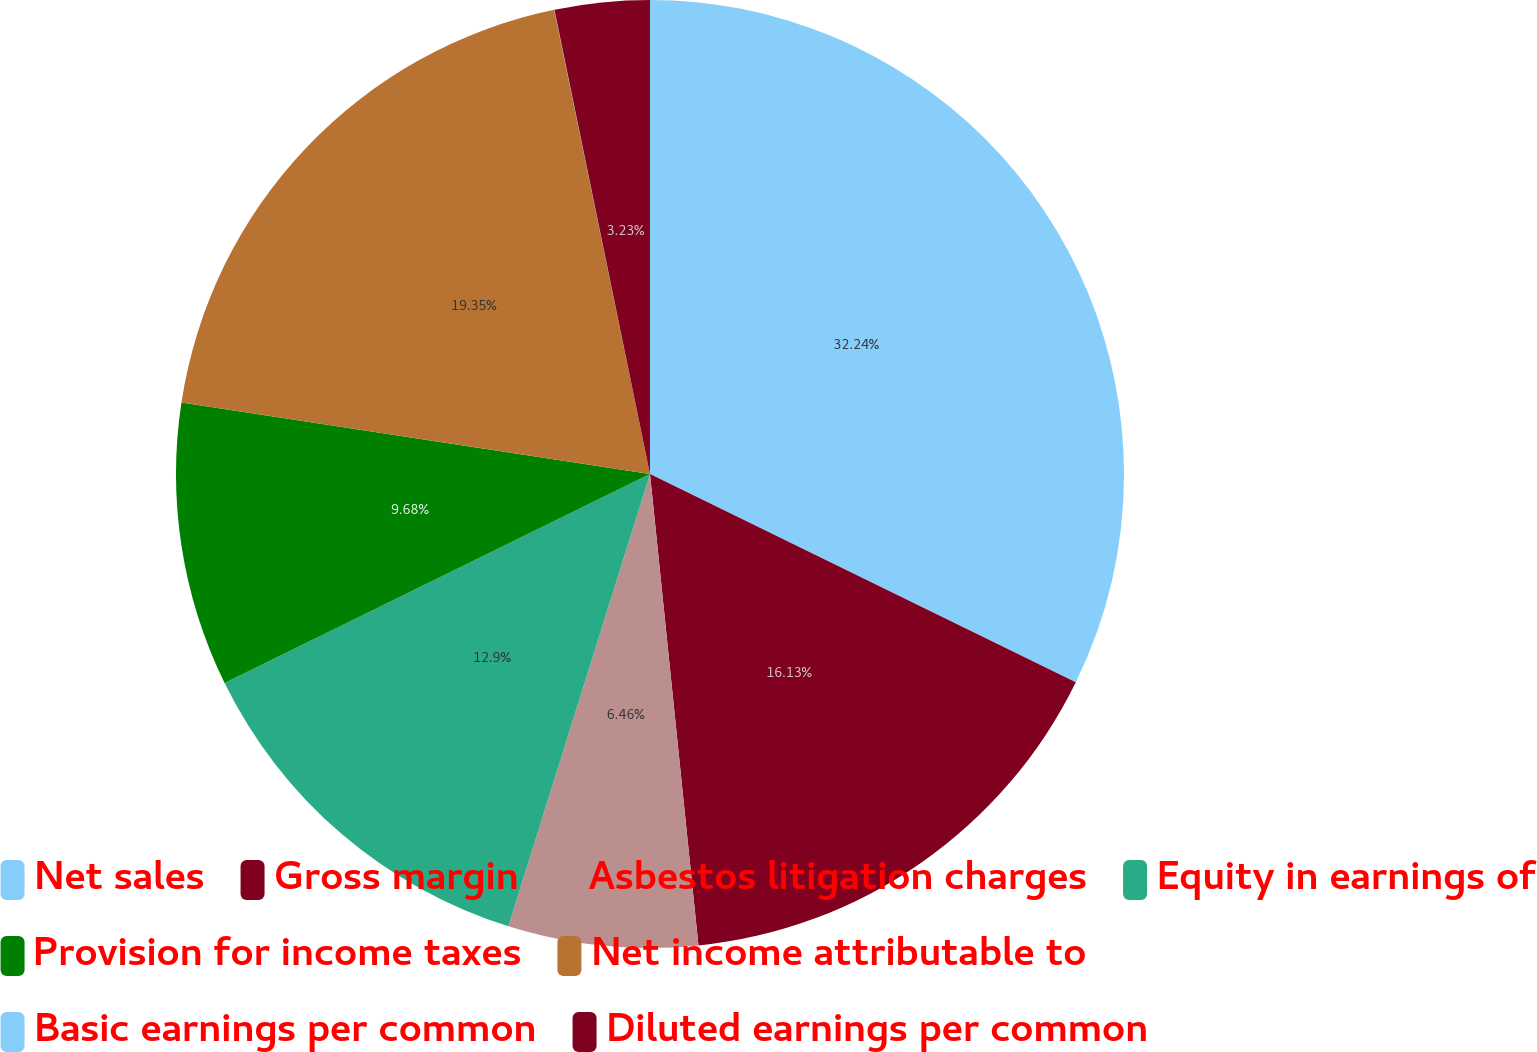<chart> <loc_0><loc_0><loc_500><loc_500><pie_chart><fcel>Net sales<fcel>Gross margin<fcel>Asbestos litigation charges<fcel>Equity in earnings of<fcel>Provision for income taxes<fcel>Net income attributable to<fcel>Basic earnings per common<fcel>Diluted earnings per common<nl><fcel>32.24%<fcel>16.13%<fcel>6.46%<fcel>12.9%<fcel>9.68%<fcel>19.35%<fcel>0.01%<fcel>3.23%<nl></chart> 